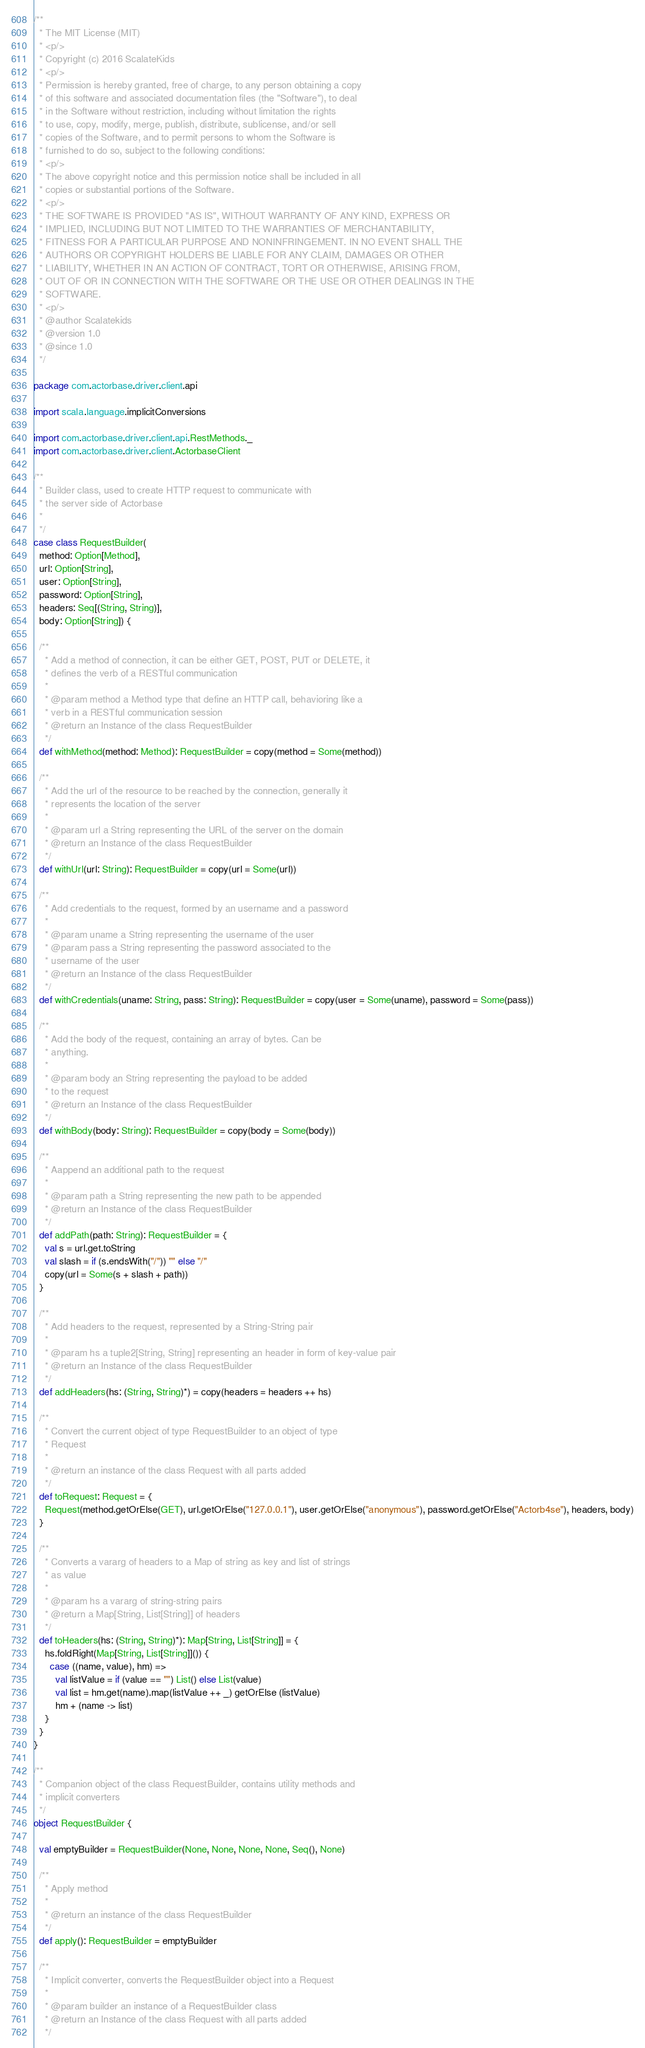Convert code to text. <code><loc_0><loc_0><loc_500><loc_500><_Scala_>/**
  * The MIT License (MIT)
  * <p/>
  * Copyright (c) 2016 ScalateKids
  * <p/>
  * Permission is hereby granted, free of charge, to any person obtaining a copy
  * of this software and associated documentation files (the "Software"), to deal
  * in the Software without restriction, including without limitation the rights
  * to use, copy, modify, merge, publish, distribute, sublicense, and/or sell
  * copies of the Software, and to permit persons to whom the Software is
  * furnished to do so, subject to the following conditions:
  * <p/>
  * The above copyright notice and this permission notice shall be included in all
  * copies or substantial portions of the Software.
  * <p/>
  * THE SOFTWARE IS PROVIDED "AS IS", WITHOUT WARRANTY OF ANY KIND, EXPRESS OR
  * IMPLIED, INCLUDING BUT NOT LIMITED TO THE WARRANTIES OF MERCHANTABILITY,
  * FITNESS FOR A PARTICULAR PURPOSE AND NONINFRINGEMENT. IN NO EVENT SHALL THE
  * AUTHORS OR COPYRIGHT HOLDERS BE LIABLE FOR ANY CLAIM, DAMAGES OR OTHER
  * LIABILITY, WHETHER IN AN ACTION OF CONTRACT, TORT OR OTHERWISE, ARISING FROM,
  * OUT OF OR IN CONNECTION WITH THE SOFTWARE OR THE USE OR OTHER DEALINGS IN THE
  * SOFTWARE.
  * <p/>
  * @author Scalatekids
  * @version 1.0
  * @since 1.0
  */

package com.actorbase.driver.client.api

import scala.language.implicitConversions

import com.actorbase.driver.client.api.RestMethods._
import com.actorbase.driver.client.ActorbaseClient

/**
  * Builder class, used to create HTTP request to communicate with
  * the server side of Actorbase
  *
  */
case class RequestBuilder(
  method: Option[Method],
  url: Option[String],
  user: Option[String],
  password: Option[String],
  headers: Seq[(String, String)],
  body: Option[String]) {

  /**
    * Add a method of connection, it can be either GET, POST, PUT or DELETE, it
    * defines the verb of a RESTful communication
    *
    * @param method a Method type that define an HTTP call, behavioring like a
    * verb in a RESTful communication session
    * @return an Instance of the class RequestBuilder
    */
  def withMethod(method: Method): RequestBuilder = copy(method = Some(method))

  /**
    * Add the url of the resource to be reached by the connection, generally it
    * represents the location of the server
    *
    * @param url a String representing the URL of the server on the domain
    * @return an Instance of the class RequestBuilder
    */
  def withUrl(url: String): RequestBuilder = copy(url = Some(url))

  /**
    * Add credentials to the request, formed by an username and a password
    *
    * @param uname a String representing the username of the user
    * @param pass a String representing the password associated to the
    * username of the user
    * @return an Instance of the class RequestBuilder
    */
  def withCredentials(uname: String, pass: String): RequestBuilder = copy(user = Some(uname), password = Some(pass))

  /**
    * Add the body of the request, containing an array of bytes. Can be
    * anything.
    *
    * @param body an String representing the payload to be added
    * to the request
    * @return an Instance of the class RequestBuilder
    */
  def withBody(body: String): RequestBuilder = copy(body = Some(body))

  /**
    * Aappend an additional path to the request
    *
    * @param path a String representing the new path to be appended
    * @return an Instance of the class RequestBuilder
    */
  def addPath(path: String): RequestBuilder = {
    val s = url.get.toString
    val slash = if (s.endsWith("/")) "" else "/"
    copy(url = Some(s + slash + path))
  }

  /**
    * Add headers to the request, represented by a String-String pair
    *
    * @param hs a tuple2[String, String] representing an header in form of key-value pair
    * @return an Instance of the class RequestBuilder
    */
  def addHeaders(hs: (String, String)*) = copy(headers = headers ++ hs)

  /**
    * Convert the current object of type RequestBuilder to an object of type
    * Request
    *
    * @return an instance of the class Request with all parts added
    */
  def toRequest: Request = {
    Request(method.getOrElse(GET), url.getOrElse("127.0.0.1"), user.getOrElse("anonymous"), password.getOrElse("Actorb4se"), headers, body)
  }

  /**
    * Converts a vararg of headers to a Map of string as key and list of strings
    * as value
    *
    * @param hs a vararg of string-string pairs
    * @return a Map[String, List[String]] of headers
    */
  def toHeaders(hs: (String, String)*): Map[String, List[String]] = {
    hs.foldRight(Map[String, List[String]]()) {
      case ((name, value), hm) =>
        val listValue = if (value == "") List() else List(value)
        val list = hm.get(name).map(listValue ++ _) getOrElse (listValue)
        hm + (name -> list)
    }
  }
}

/**
  * Companion object of the class RequestBuilder, contains utility methods and
  * implicit converters
  */
object RequestBuilder {

  val emptyBuilder = RequestBuilder(None, None, None, None, Seq(), None)

  /**
    * Apply method
    *
    * @return an instance of the class RequestBuilder
    */
  def apply(): RequestBuilder = emptyBuilder

  /**
    * Implicit converter, converts the RequestBuilder object into a Request
    *
    * @param builder an instance of a RequestBuilder class
    * @return an Instance of the class Request with all parts added
    */</code> 